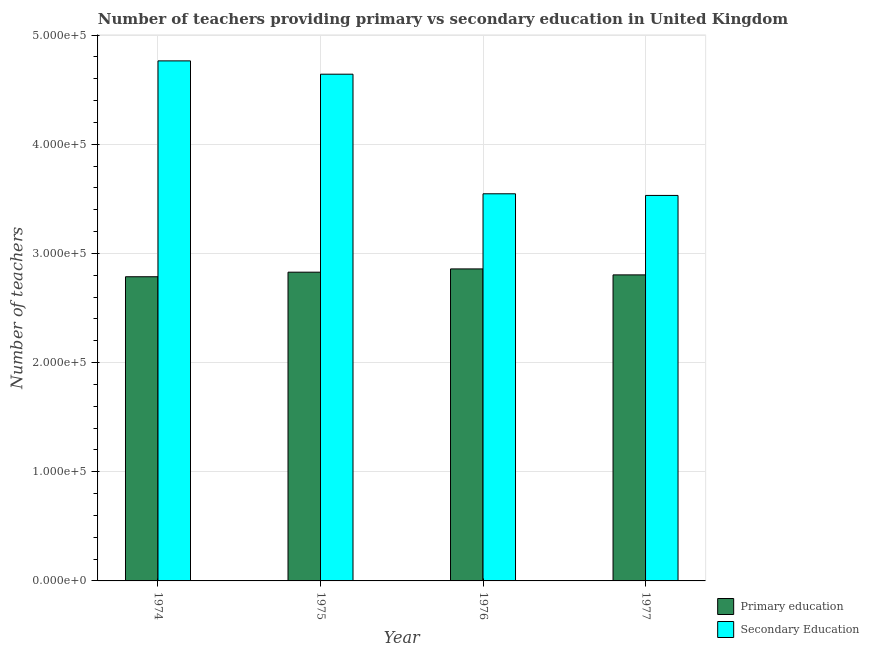How many groups of bars are there?
Offer a terse response. 4. How many bars are there on the 3rd tick from the left?
Your answer should be compact. 2. What is the label of the 2nd group of bars from the left?
Make the answer very short. 1975. In how many cases, is the number of bars for a given year not equal to the number of legend labels?
Make the answer very short. 0. What is the number of secondary teachers in 1974?
Keep it short and to the point. 4.76e+05. Across all years, what is the maximum number of secondary teachers?
Keep it short and to the point. 4.76e+05. Across all years, what is the minimum number of secondary teachers?
Your answer should be very brief. 3.53e+05. In which year was the number of primary teachers maximum?
Ensure brevity in your answer.  1976. In which year was the number of primary teachers minimum?
Your answer should be very brief. 1974. What is the total number of secondary teachers in the graph?
Ensure brevity in your answer.  1.65e+06. What is the difference between the number of primary teachers in 1976 and that in 1977?
Keep it short and to the point. 5471. What is the difference between the number of secondary teachers in 1974 and the number of primary teachers in 1977?
Your answer should be very brief. 1.23e+05. What is the average number of primary teachers per year?
Offer a terse response. 2.82e+05. What is the ratio of the number of primary teachers in 1974 to that in 1975?
Keep it short and to the point. 0.99. What is the difference between the highest and the second highest number of primary teachers?
Offer a very short reply. 2993. What is the difference between the highest and the lowest number of secondary teachers?
Ensure brevity in your answer.  1.23e+05. What does the 2nd bar from the left in 1975 represents?
Offer a terse response. Secondary Education. What does the 2nd bar from the right in 1977 represents?
Your answer should be compact. Primary education. Are all the bars in the graph horizontal?
Offer a very short reply. No. What is the difference between two consecutive major ticks on the Y-axis?
Your answer should be compact. 1.00e+05. Are the values on the major ticks of Y-axis written in scientific E-notation?
Give a very brief answer. Yes. How many legend labels are there?
Keep it short and to the point. 2. How are the legend labels stacked?
Ensure brevity in your answer.  Vertical. What is the title of the graph?
Keep it short and to the point. Number of teachers providing primary vs secondary education in United Kingdom. What is the label or title of the X-axis?
Your response must be concise. Year. What is the label or title of the Y-axis?
Ensure brevity in your answer.  Number of teachers. What is the Number of teachers of Primary education in 1974?
Provide a succinct answer. 2.79e+05. What is the Number of teachers of Secondary Education in 1974?
Your answer should be compact. 4.76e+05. What is the Number of teachers in Primary education in 1975?
Your response must be concise. 2.83e+05. What is the Number of teachers in Secondary Education in 1975?
Your answer should be compact. 4.64e+05. What is the Number of teachers in Primary education in 1976?
Make the answer very short. 2.86e+05. What is the Number of teachers of Secondary Education in 1976?
Ensure brevity in your answer.  3.55e+05. What is the Number of teachers of Primary education in 1977?
Your answer should be compact. 2.80e+05. What is the Number of teachers of Secondary Education in 1977?
Your answer should be very brief. 3.53e+05. Across all years, what is the maximum Number of teachers of Primary education?
Ensure brevity in your answer.  2.86e+05. Across all years, what is the maximum Number of teachers of Secondary Education?
Your answer should be compact. 4.76e+05. Across all years, what is the minimum Number of teachers in Primary education?
Give a very brief answer. 2.79e+05. Across all years, what is the minimum Number of teachers in Secondary Education?
Ensure brevity in your answer.  3.53e+05. What is the total Number of teachers in Primary education in the graph?
Make the answer very short. 1.13e+06. What is the total Number of teachers of Secondary Education in the graph?
Your answer should be compact. 1.65e+06. What is the difference between the Number of teachers of Primary education in 1974 and that in 1975?
Your answer should be compact. -4184. What is the difference between the Number of teachers of Secondary Education in 1974 and that in 1975?
Give a very brief answer. 1.22e+04. What is the difference between the Number of teachers of Primary education in 1974 and that in 1976?
Provide a succinct answer. -7177. What is the difference between the Number of teachers in Secondary Education in 1974 and that in 1976?
Offer a very short reply. 1.22e+05. What is the difference between the Number of teachers of Primary education in 1974 and that in 1977?
Your answer should be very brief. -1706. What is the difference between the Number of teachers in Secondary Education in 1974 and that in 1977?
Offer a terse response. 1.23e+05. What is the difference between the Number of teachers in Primary education in 1975 and that in 1976?
Offer a very short reply. -2993. What is the difference between the Number of teachers of Secondary Education in 1975 and that in 1976?
Keep it short and to the point. 1.10e+05. What is the difference between the Number of teachers in Primary education in 1975 and that in 1977?
Your answer should be very brief. 2478. What is the difference between the Number of teachers in Secondary Education in 1975 and that in 1977?
Keep it short and to the point. 1.11e+05. What is the difference between the Number of teachers of Primary education in 1976 and that in 1977?
Provide a short and direct response. 5471. What is the difference between the Number of teachers of Secondary Education in 1976 and that in 1977?
Give a very brief answer. 1498. What is the difference between the Number of teachers in Primary education in 1974 and the Number of teachers in Secondary Education in 1975?
Give a very brief answer. -1.86e+05. What is the difference between the Number of teachers in Primary education in 1974 and the Number of teachers in Secondary Education in 1976?
Your answer should be very brief. -7.60e+04. What is the difference between the Number of teachers in Primary education in 1974 and the Number of teachers in Secondary Education in 1977?
Give a very brief answer. -7.45e+04. What is the difference between the Number of teachers of Primary education in 1975 and the Number of teachers of Secondary Education in 1976?
Ensure brevity in your answer.  -7.18e+04. What is the difference between the Number of teachers of Primary education in 1975 and the Number of teachers of Secondary Education in 1977?
Offer a terse response. -7.03e+04. What is the difference between the Number of teachers in Primary education in 1976 and the Number of teachers in Secondary Education in 1977?
Your answer should be very brief. -6.73e+04. What is the average Number of teachers in Primary education per year?
Your answer should be compact. 2.82e+05. What is the average Number of teachers of Secondary Education per year?
Provide a short and direct response. 4.12e+05. In the year 1974, what is the difference between the Number of teachers in Primary education and Number of teachers in Secondary Education?
Give a very brief answer. -1.98e+05. In the year 1975, what is the difference between the Number of teachers of Primary education and Number of teachers of Secondary Education?
Provide a succinct answer. -1.81e+05. In the year 1976, what is the difference between the Number of teachers in Primary education and Number of teachers in Secondary Education?
Provide a short and direct response. -6.88e+04. In the year 1977, what is the difference between the Number of teachers in Primary education and Number of teachers in Secondary Education?
Provide a succinct answer. -7.28e+04. What is the ratio of the Number of teachers of Primary education in 1974 to that in 1975?
Provide a short and direct response. 0.99. What is the ratio of the Number of teachers of Secondary Education in 1974 to that in 1975?
Your answer should be very brief. 1.03. What is the ratio of the Number of teachers in Primary education in 1974 to that in 1976?
Offer a terse response. 0.97. What is the ratio of the Number of teachers in Secondary Education in 1974 to that in 1976?
Your answer should be very brief. 1.34. What is the ratio of the Number of teachers in Primary education in 1974 to that in 1977?
Provide a short and direct response. 0.99. What is the ratio of the Number of teachers of Secondary Education in 1974 to that in 1977?
Provide a short and direct response. 1.35. What is the ratio of the Number of teachers in Primary education in 1975 to that in 1976?
Provide a succinct answer. 0.99. What is the ratio of the Number of teachers in Secondary Education in 1975 to that in 1976?
Make the answer very short. 1.31. What is the ratio of the Number of teachers of Primary education in 1975 to that in 1977?
Your answer should be compact. 1.01. What is the ratio of the Number of teachers of Secondary Education in 1975 to that in 1977?
Your response must be concise. 1.31. What is the ratio of the Number of teachers in Primary education in 1976 to that in 1977?
Give a very brief answer. 1.02. What is the ratio of the Number of teachers in Secondary Education in 1976 to that in 1977?
Give a very brief answer. 1. What is the difference between the highest and the second highest Number of teachers of Primary education?
Offer a very short reply. 2993. What is the difference between the highest and the second highest Number of teachers of Secondary Education?
Provide a succinct answer. 1.22e+04. What is the difference between the highest and the lowest Number of teachers in Primary education?
Your response must be concise. 7177. What is the difference between the highest and the lowest Number of teachers in Secondary Education?
Ensure brevity in your answer.  1.23e+05. 